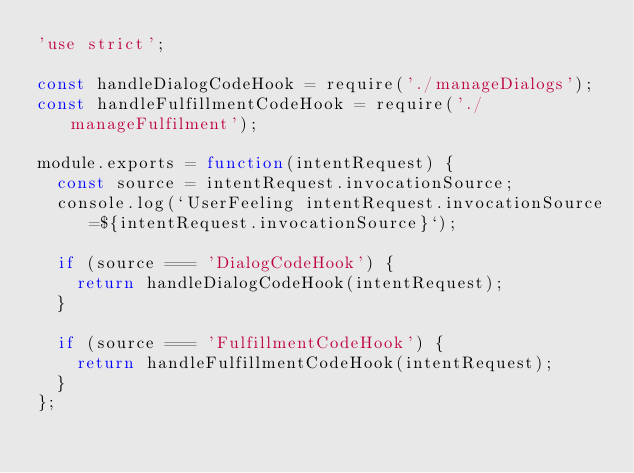Convert code to text. <code><loc_0><loc_0><loc_500><loc_500><_JavaScript_>'use strict';

const handleDialogCodeHook = require('./manageDialogs');
const handleFulfillmentCodeHook = require('./manageFulfilment');

module.exports = function(intentRequest) {
  const source = intentRequest.invocationSource;
  console.log(`UserFeeling intentRequest.invocationSource=${intentRequest.invocationSource}`);

  if (source === 'DialogCodeHook') {
    return handleDialogCodeHook(intentRequest);
  }

  if (source === 'FulfillmentCodeHook') {
    return handleFulfillmentCodeHook(intentRequest);
  }
};
</code> 